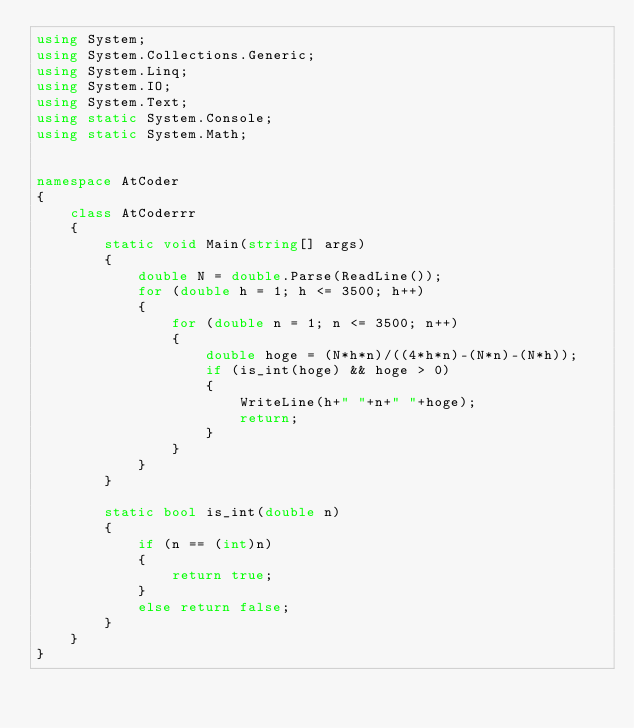<code> <loc_0><loc_0><loc_500><loc_500><_C#_>using System;
using System.Collections.Generic;
using System.Linq;
using System.IO;
using System.Text;
using static System.Console;
using static System.Math;


namespace AtCoder
{
    class AtCoderrr
    {
        static void Main(string[] args)
        {
            double N = double.Parse(ReadLine());
            for (double h = 1; h <= 3500; h++)
            {
                for (double n = 1; n <= 3500; n++)
                {
                    double hoge = (N*h*n)/((4*h*n)-(N*n)-(N*h));
                    if (is_int(hoge) && hoge > 0)
                    {
                        WriteLine(h+" "+n+" "+hoge);
                        return;
                    }
                }
            }
        }

        static bool is_int(double n)
        {
            if (n == (int)n)
            {
                return true;
            }
            else return false;
        }
    }
}
</code> 